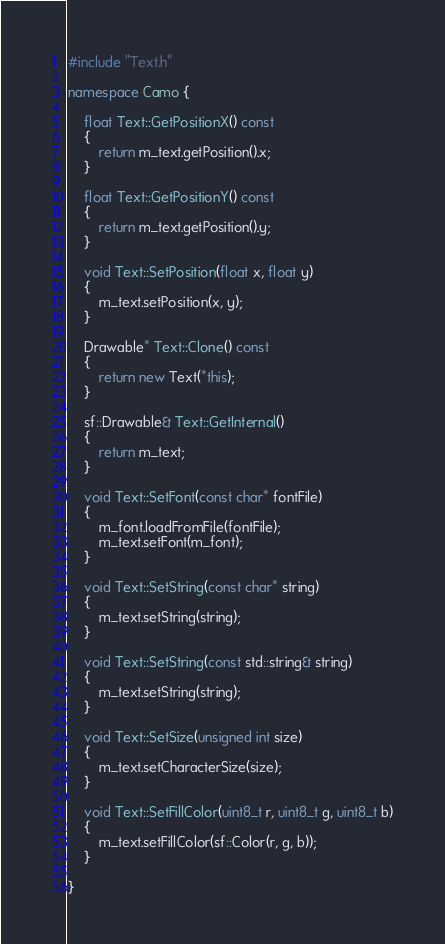<code> <loc_0><loc_0><loc_500><loc_500><_C++_>#include "Text.h"

namespace Camo {

	float Text::GetPositionX() const
	{
		return m_text.getPosition().x;
	}

	float Text::GetPositionY() const
	{
		return m_text.getPosition().y;
	}

	void Text::SetPosition(float x, float y)
	{
		m_text.setPosition(x, y);
	}

	Drawable* Text::Clone() const
	{
		return new Text(*this);
	}

	sf::Drawable& Text::GetInternal()
	{
		return m_text;
	}

	void Text::SetFont(const char* fontFile)
	{
		m_font.loadFromFile(fontFile);
		m_text.setFont(m_font);
	}

	void Text::SetString(const char* string)
	{
		m_text.setString(string);
	}

	void Text::SetString(const std::string& string)
	{
		m_text.setString(string);
	}

	void Text::SetSize(unsigned int size)
	{
		m_text.setCharacterSize(size);
	}

	void Text::SetFillColor(uint8_t r, uint8_t g, uint8_t b)
	{
		m_text.setFillColor(sf::Color(r, g, b));
	}

}</code> 